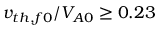<formula> <loc_0><loc_0><loc_500><loc_500>v _ { t h , f 0 } / V _ { A 0 } \geq 0 . 2 3</formula> 